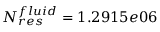Convert formula to latex. <formula><loc_0><loc_0><loc_500><loc_500>N _ { r e s } ^ { f l u i d } = 1 . 2 9 1 5 e 0 6</formula> 